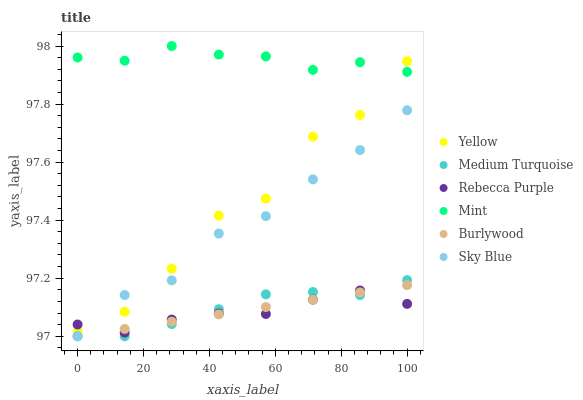Does Rebecca Purple have the minimum area under the curve?
Answer yes or no. Yes. Does Mint have the maximum area under the curve?
Answer yes or no. Yes. Does Yellow have the minimum area under the curve?
Answer yes or no. No. Does Yellow have the maximum area under the curve?
Answer yes or no. No. Is Burlywood the smoothest?
Answer yes or no. Yes. Is Yellow the roughest?
Answer yes or no. Yes. Is Rebecca Purple the smoothest?
Answer yes or no. No. Is Rebecca Purple the roughest?
Answer yes or no. No. Does Burlywood have the lowest value?
Answer yes or no. Yes. Does Yellow have the lowest value?
Answer yes or no. No. Does Mint have the highest value?
Answer yes or no. Yes. Does Yellow have the highest value?
Answer yes or no. No. Is Medium Turquoise less than Yellow?
Answer yes or no. Yes. Is Mint greater than Medium Turquoise?
Answer yes or no. Yes. Does Medium Turquoise intersect Burlywood?
Answer yes or no. Yes. Is Medium Turquoise less than Burlywood?
Answer yes or no. No. Is Medium Turquoise greater than Burlywood?
Answer yes or no. No. Does Medium Turquoise intersect Yellow?
Answer yes or no. No. 